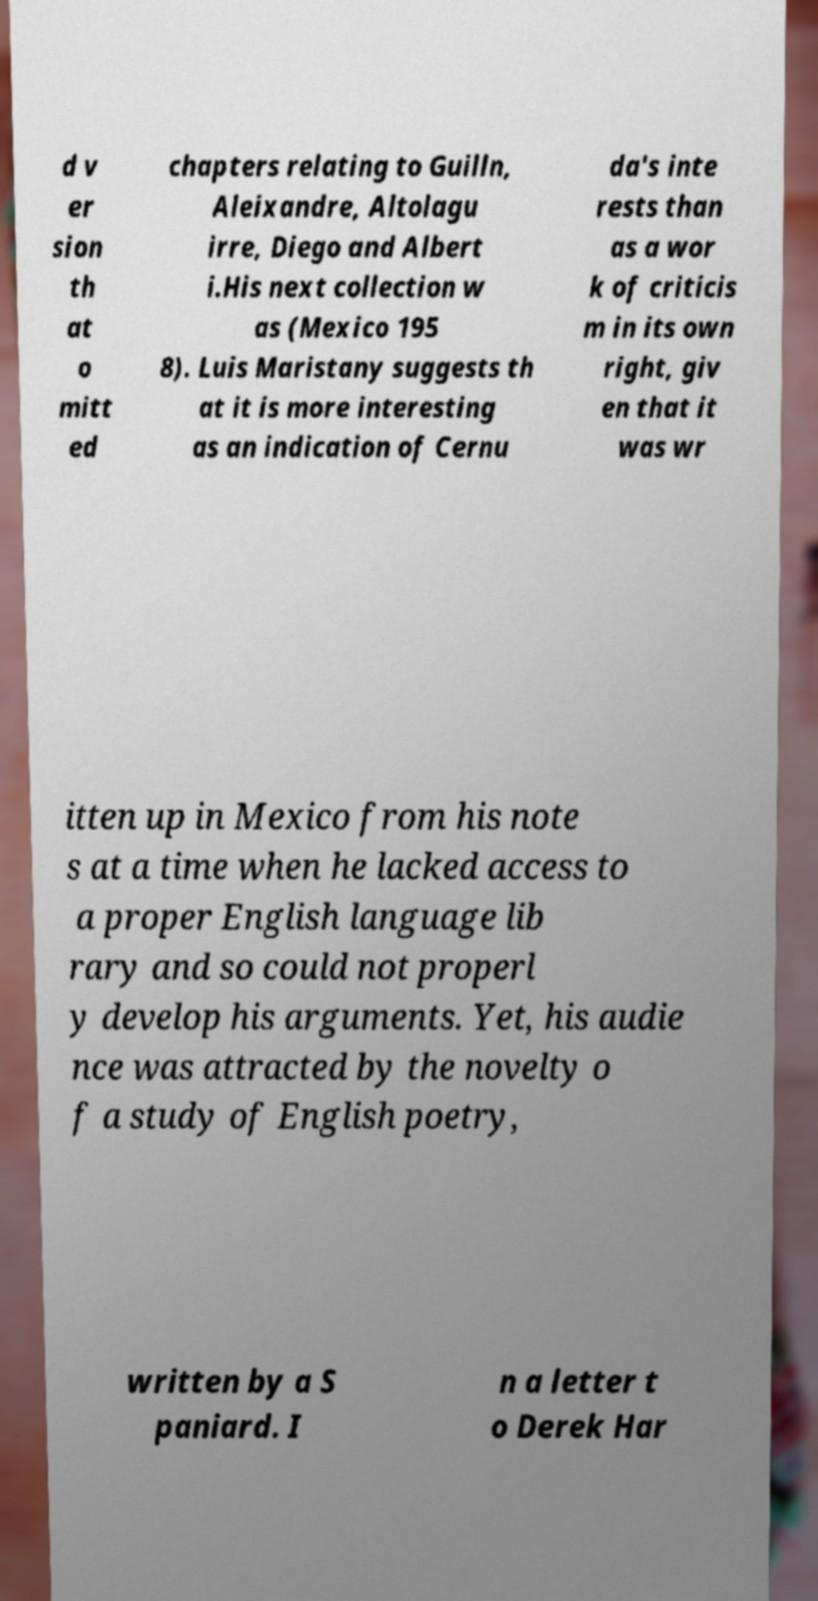Could you extract and type out the text from this image? d v er sion th at o mitt ed chapters relating to Guilln, Aleixandre, Altolagu irre, Diego and Albert i.His next collection w as (Mexico 195 8). Luis Maristany suggests th at it is more interesting as an indication of Cernu da's inte rests than as a wor k of criticis m in its own right, giv en that it was wr itten up in Mexico from his note s at a time when he lacked access to a proper English language lib rary and so could not properl y develop his arguments. Yet, his audie nce was attracted by the novelty o f a study of English poetry, written by a S paniard. I n a letter t o Derek Har 